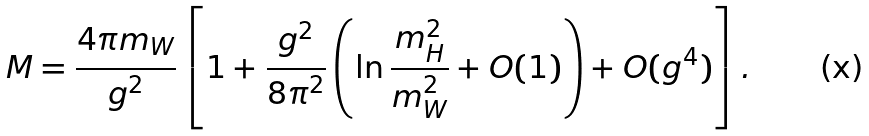<formula> <loc_0><loc_0><loc_500><loc_500>M = \frac { 4 \pi m _ { W } } { g ^ { 2 } } \left [ 1 + \frac { g ^ { 2 } } { 8 \pi ^ { 2 } } \left ( \ln \frac { m _ { H } ^ { 2 } } { m _ { W } ^ { 2 } } + O ( 1 ) \right ) + O ( g ^ { 4 } ) \right ] .</formula> 